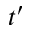<formula> <loc_0><loc_0><loc_500><loc_500>t ^ { \prime }</formula> 